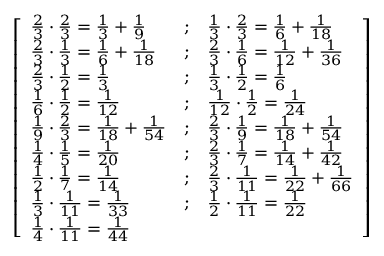Convert formula to latex. <formula><loc_0><loc_0><loc_500><loc_500>{ \left [ \begin{array} { l l l } { { \frac { 2 } { 3 } } \cdot { \frac { 2 } { 3 } } = { \frac { 1 } { 3 } } + { \frac { 1 } { 9 } } } & { ; } & { { \frac { 1 } { 3 } } \cdot { \frac { 2 } { 3 } } = { \frac { 1 } { 6 } } + { \frac { 1 } { 1 8 } } } \\ { { \frac { 2 } { 3 } } \cdot { \frac { 1 } { 3 } } = { \frac { 1 } { 6 } } + { \frac { 1 } { 1 8 } } } & { ; } & { { \frac { 2 } { 3 } } \cdot { \frac { 1 } { 6 } } = { \frac { 1 } { 1 2 } } + { \frac { 1 } { 3 6 } } } \\ { { \frac { 2 } { 3 } } \cdot { \frac { 1 } { 2 } } = { \frac { 1 } { 3 } } } & { ; } & { { \frac { 1 } { 3 } } \cdot { \frac { 1 } { 2 } } = { \frac { 1 } { 6 } } } \\ { { \frac { 1 } { 6 } } \cdot { \frac { 1 } { 2 } } = { \frac { 1 } { 1 2 } } } & { ; } & { { \frac { 1 } { 1 2 } } \cdot { \frac { 1 } { 2 } } = { \frac { 1 } { 2 4 } } } \\ { { \frac { 1 } { 9 } } \cdot { \frac { 2 } { 3 } } = { \frac { 1 } { 1 8 } } + { \frac { 1 } { 5 4 } } } & { ; } & { { \frac { 2 } { 3 } } \cdot { \frac { 1 } { 9 } } = { \frac { 1 } { 1 8 } } + { \frac { 1 } { 5 4 } } } \\ { { \frac { 1 } { 4 } } \cdot { \frac { 1 } { 5 } } = { \frac { 1 } { 2 0 } } } & { ; } & { { \frac { 2 } { 3 } } \cdot { \frac { 1 } { 7 } } = { \frac { 1 } { 1 4 } } + { \frac { 1 } { 4 2 } } } \\ { { \frac { 1 } { 2 } } \cdot { \frac { 1 } { 7 } } = { \frac { 1 } { 1 4 } } } & { ; } & { { \frac { 2 } { 3 } } \cdot { \frac { 1 } { 1 1 } } = { \frac { 1 } { 2 2 } } + { \frac { 1 } { 6 6 } } } \\ { { \frac { 1 } { 3 } } \cdot { \frac { 1 } { 1 1 } } = { \frac { 1 } { 3 3 } } } & { ; } & { { \frac { 1 } { 2 } } \cdot { \frac { 1 } { 1 1 } } = { \frac { 1 } { 2 2 } } } \\ { { \frac { 1 } { 4 } } \cdot { \frac { 1 } { 1 1 } } = { \frac { 1 } { 4 4 } } } & & \end{array} \right ] }</formula> 